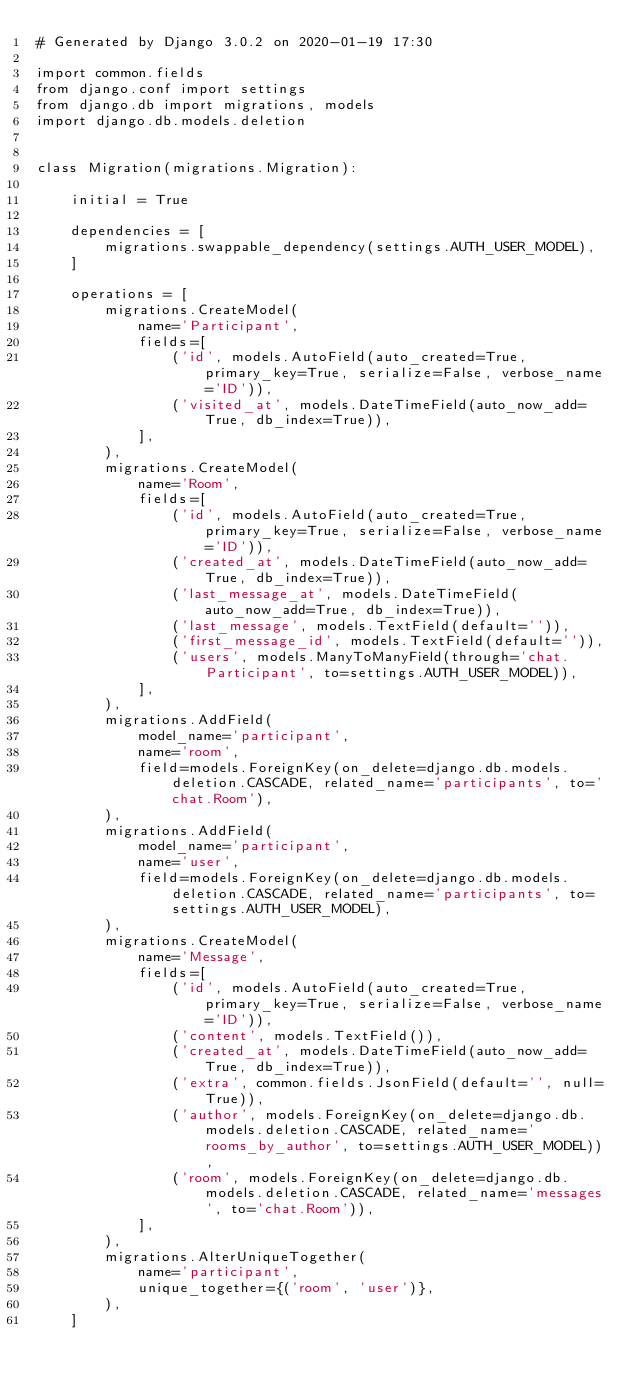Convert code to text. <code><loc_0><loc_0><loc_500><loc_500><_Python_># Generated by Django 3.0.2 on 2020-01-19 17:30

import common.fields
from django.conf import settings
from django.db import migrations, models
import django.db.models.deletion


class Migration(migrations.Migration):

    initial = True

    dependencies = [
        migrations.swappable_dependency(settings.AUTH_USER_MODEL),
    ]

    operations = [
        migrations.CreateModel(
            name='Participant',
            fields=[
                ('id', models.AutoField(auto_created=True, primary_key=True, serialize=False, verbose_name='ID')),
                ('visited_at', models.DateTimeField(auto_now_add=True, db_index=True)),
            ],
        ),
        migrations.CreateModel(
            name='Room',
            fields=[
                ('id', models.AutoField(auto_created=True, primary_key=True, serialize=False, verbose_name='ID')),
                ('created_at', models.DateTimeField(auto_now_add=True, db_index=True)),
                ('last_message_at', models.DateTimeField(auto_now_add=True, db_index=True)),
                ('last_message', models.TextField(default='')),
                ('first_message_id', models.TextField(default='')),
                ('users', models.ManyToManyField(through='chat.Participant', to=settings.AUTH_USER_MODEL)),
            ],
        ),
        migrations.AddField(
            model_name='participant',
            name='room',
            field=models.ForeignKey(on_delete=django.db.models.deletion.CASCADE, related_name='participants', to='chat.Room'),
        ),
        migrations.AddField(
            model_name='participant',
            name='user',
            field=models.ForeignKey(on_delete=django.db.models.deletion.CASCADE, related_name='participants', to=settings.AUTH_USER_MODEL),
        ),
        migrations.CreateModel(
            name='Message',
            fields=[
                ('id', models.AutoField(auto_created=True, primary_key=True, serialize=False, verbose_name='ID')),
                ('content', models.TextField()),
                ('created_at', models.DateTimeField(auto_now_add=True, db_index=True)),
                ('extra', common.fields.JsonField(default='', null=True)),
                ('author', models.ForeignKey(on_delete=django.db.models.deletion.CASCADE, related_name='rooms_by_author', to=settings.AUTH_USER_MODEL)),
                ('room', models.ForeignKey(on_delete=django.db.models.deletion.CASCADE, related_name='messages', to='chat.Room')),
            ],
        ),
        migrations.AlterUniqueTogether(
            name='participant',
            unique_together={('room', 'user')},
        ),
    ]
</code> 